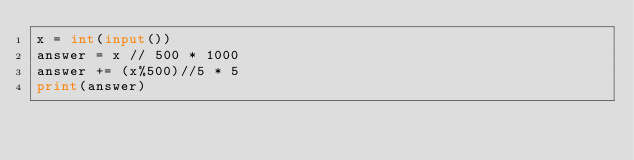<code> <loc_0><loc_0><loc_500><loc_500><_Python_>x = int(input())
answer = x // 500 * 1000
answer += (x%500)//5 * 5
print(answer)</code> 